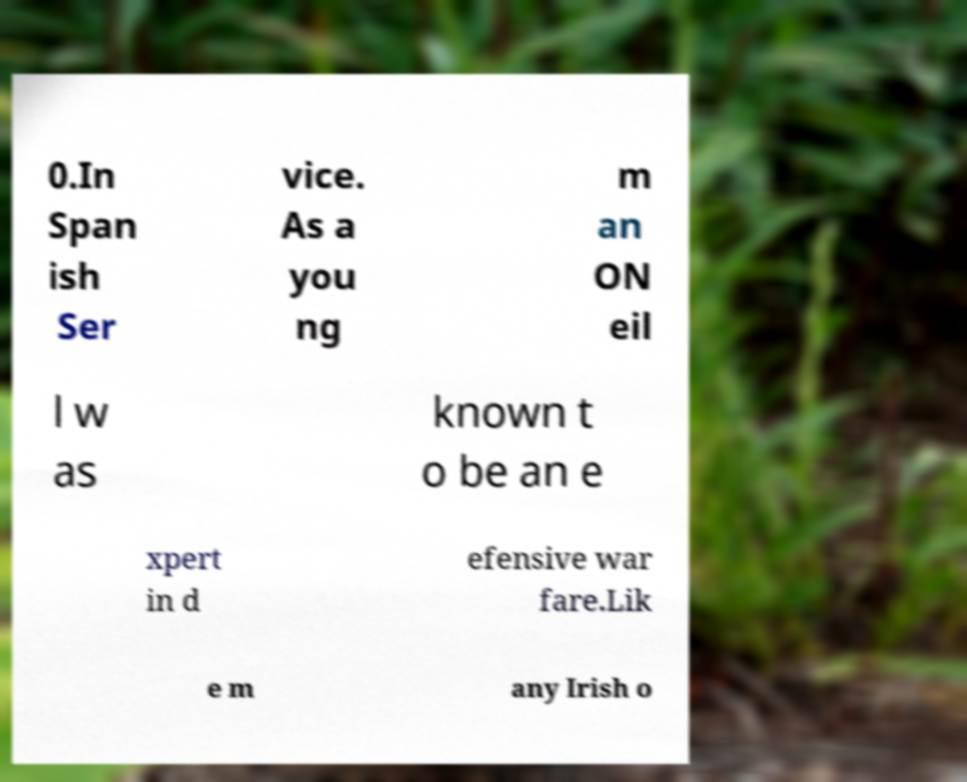I need the written content from this picture converted into text. Can you do that? 0.In Span ish Ser vice. As a you ng m an ON eil l w as known t o be an e xpert in d efensive war fare.Lik e m any Irish o 